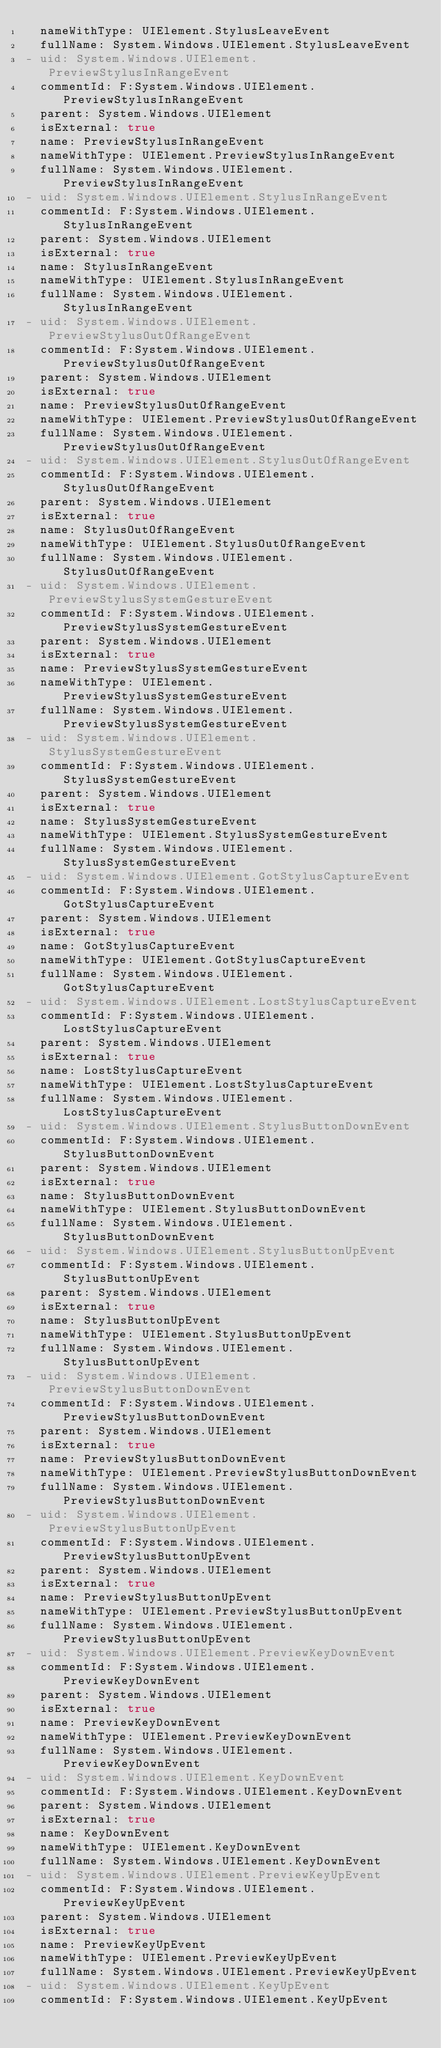<code> <loc_0><loc_0><loc_500><loc_500><_YAML_>  nameWithType: UIElement.StylusLeaveEvent
  fullName: System.Windows.UIElement.StylusLeaveEvent
- uid: System.Windows.UIElement.PreviewStylusInRangeEvent
  commentId: F:System.Windows.UIElement.PreviewStylusInRangeEvent
  parent: System.Windows.UIElement
  isExternal: true
  name: PreviewStylusInRangeEvent
  nameWithType: UIElement.PreviewStylusInRangeEvent
  fullName: System.Windows.UIElement.PreviewStylusInRangeEvent
- uid: System.Windows.UIElement.StylusInRangeEvent
  commentId: F:System.Windows.UIElement.StylusInRangeEvent
  parent: System.Windows.UIElement
  isExternal: true
  name: StylusInRangeEvent
  nameWithType: UIElement.StylusInRangeEvent
  fullName: System.Windows.UIElement.StylusInRangeEvent
- uid: System.Windows.UIElement.PreviewStylusOutOfRangeEvent
  commentId: F:System.Windows.UIElement.PreviewStylusOutOfRangeEvent
  parent: System.Windows.UIElement
  isExternal: true
  name: PreviewStylusOutOfRangeEvent
  nameWithType: UIElement.PreviewStylusOutOfRangeEvent
  fullName: System.Windows.UIElement.PreviewStylusOutOfRangeEvent
- uid: System.Windows.UIElement.StylusOutOfRangeEvent
  commentId: F:System.Windows.UIElement.StylusOutOfRangeEvent
  parent: System.Windows.UIElement
  isExternal: true
  name: StylusOutOfRangeEvent
  nameWithType: UIElement.StylusOutOfRangeEvent
  fullName: System.Windows.UIElement.StylusOutOfRangeEvent
- uid: System.Windows.UIElement.PreviewStylusSystemGestureEvent
  commentId: F:System.Windows.UIElement.PreviewStylusSystemGestureEvent
  parent: System.Windows.UIElement
  isExternal: true
  name: PreviewStylusSystemGestureEvent
  nameWithType: UIElement.PreviewStylusSystemGestureEvent
  fullName: System.Windows.UIElement.PreviewStylusSystemGestureEvent
- uid: System.Windows.UIElement.StylusSystemGestureEvent
  commentId: F:System.Windows.UIElement.StylusSystemGestureEvent
  parent: System.Windows.UIElement
  isExternal: true
  name: StylusSystemGestureEvent
  nameWithType: UIElement.StylusSystemGestureEvent
  fullName: System.Windows.UIElement.StylusSystemGestureEvent
- uid: System.Windows.UIElement.GotStylusCaptureEvent
  commentId: F:System.Windows.UIElement.GotStylusCaptureEvent
  parent: System.Windows.UIElement
  isExternal: true
  name: GotStylusCaptureEvent
  nameWithType: UIElement.GotStylusCaptureEvent
  fullName: System.Windows.UIElement.GotStylusCaptureEvent
- uid: System.Windows.UIElement.LostStylusCaptureEvent
  commentId: F:System.Windows.UIElement.LostStylusCaptureEvent
  parent: System.Windows.UIElement
  isExternal: true
  name: LostStylusCaptureEvent
  nameWithType: UIElement.LostStylusCaptureEvent
  fullName: System.Windows.UIElement.LostStylusCaptureEvent
- uid: System.Windows.UIElement.StylusButtonDownEvent
  commentId: F:System.Windows.UIElement.StylusButtonDownEvent
  parent: System.Windows.UIElement
  isExternal: true
  name: StylusButtonDownEvent
  nameWithType: UIElement.StylusButtonDownEvent
  fullName: System.Windows.UIElement.StylusButtonDownEvent
- uid: System.Windows.UIElement.StylusButtonUpEvent
  commentId: F:System.Windows.UIElement.StylusButtonUpEvent
  parent: System.Windows.UIElement
  isExternal: true
  name: StylusButtonUpEvent
  nameWithType: UIElement.StylusButtonUpEvent
  fullName: System.Windows.UIElement.StylusButtonUpEvent
- uid: System.Windows.UIElement.PreviewStylusButtonDownEvent
  commentId: F:System.Windows.UIElement.PreviewStylusButtonDownEvent
  parent: System.Windows.UIElement
  isExternal: true
  name: PreviewStylusButtonDownEvent
  nameWithType: UIElement.PreviewStylusButtonDownEvent
  fullName: System.Windows.UIElement.PreviewStylusButtonDownEvent
- uid: System.Windows.UIElement.PreviewStylusButtonUpEvent
  commentId: F:System.Windows.UIElement.PreviewStylusButtonUpEvent
  parent: System.Windows.UIElement
  isExternal: true
  name: PreviewStylusButtonUpEvent
  nameWithType: UIElement.PreviewStylusButtonUpEvent
  fullName: System.Windows.UIElement.PreviewStylusButtonUpEvent
- uid: System.Windows.UIElement.PreviewKeyDownEvent
  commentId: F:System.Windows.UIElement.PreviewKeyDownEvent
  parent: System.Windows.UIElement
  isExternal: true
  name: PreviewKeyDownEvent
  nameWithType: UIElement.PreviewKeyDownEvent
  fullName: System.Windows.UIElement.PreviewKeyDownEvent
- uid: System.Windows.UIElement.KeyDownEvent
  commentId: F:System.Windows.UIElement.KeyDownEvent
  parent: System.Windows.UIElement
  isExternal: true
  name: KeyDownEvent
  nameWithType: UIElement.KeyDownEvent
  fullName: System.Windows.UIElement.KeyDownEvent
- uid: System.Windows.UIElement.PreviewKeyUpEvent
  commentId: F:System.Windows.UIElement.PreviewKeyUpEvent
  parent: System.Windows.UIElement
  isExternal: true
  name: PreviewKeyUpEvent
  nameWithType: UIElement.PreviewKeyUpEvent
  fullName: System.Windows.UIElement.PreviewKeyUpEvent
- uid: System.Windows.UIElement.KeyUpEvent
  commentId: F:System.Windows.UIElement.KeyUpEvent</code> 